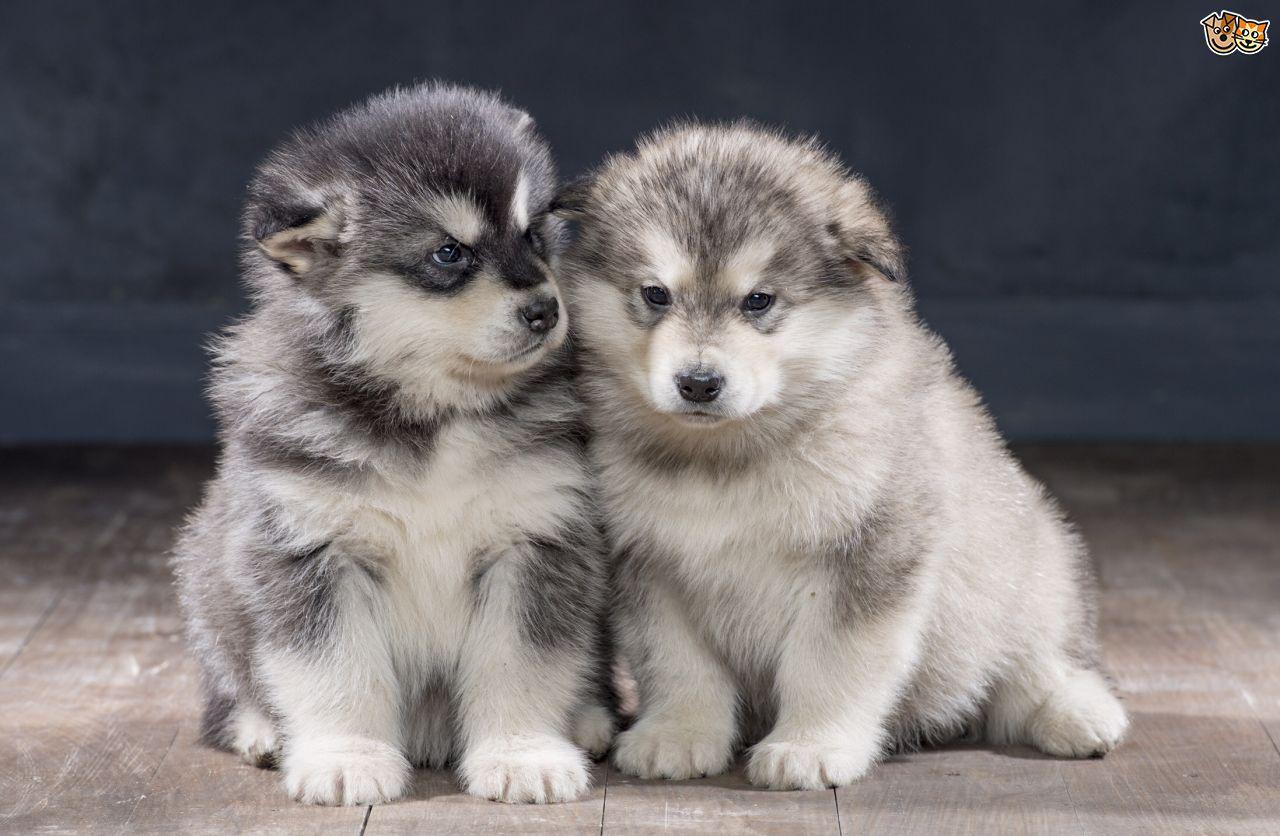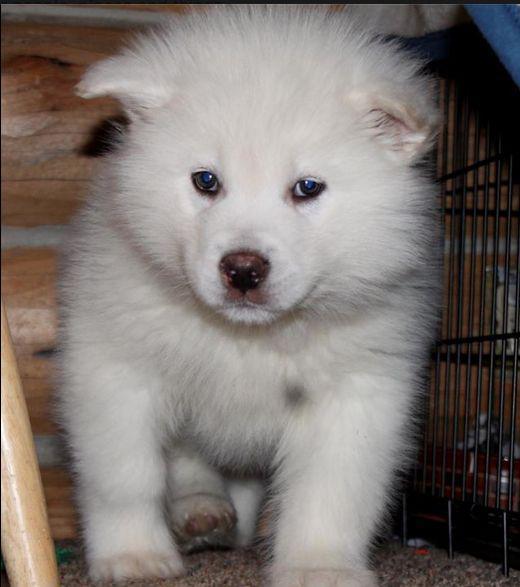The first image is the image on the left, the second image is the image on the right. For the images displayed, is the sentence "There are two Huskies in one image and a single Husky in another image." factually correct? Answer yes or no. Yes. The first image is the image on the left, the second image is the image on the right. Given the left and right images, does the statement "The left image contains two side-by-side puppies who are facing forward and sitting upright." hold true? Answer yes or no. Yes. 